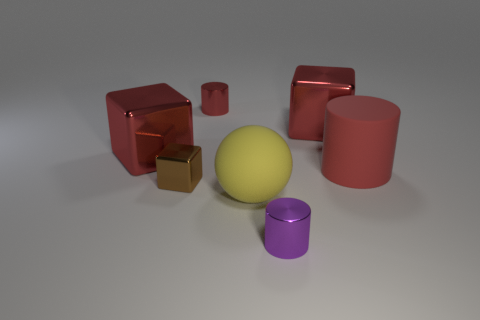How many big balls have the same color as the small shiny cube?
Your response must be concise. 0. How many things are metal cubes that are behind the red matte cylinder or tiny things in front of the brown metallic object?
Your answer should be very brief. 3. There is a rubber object to the left of the red rubber thing; what number of small purple metal cylinders are behind it?
Offer a very short reply. 0. What color is the other cylinder that is made of the same material as the tiny purple cylinder?
Give a very brief answer. Red. Is there a blue block that has the same size as the purple metallic thing?
Offer a very short reply. No. What is the shape of the rubber thing that is the same size as the rubber sphere?
Keep it short and to the point. Cylinder. Is there another tiny shiny thing of the same shape as the brown metal thing?
Your response must be concise. No. Do the big ball and the block that is in front of the big red cylinder have the same material?
Provide a short and direct response. No. Are there any tiny shiny cylinders of the same color as the small metal cube?
Your response must be concise. No. How many other things are the same material as the small red cylinder?
Provide a succinct answer. 4. 